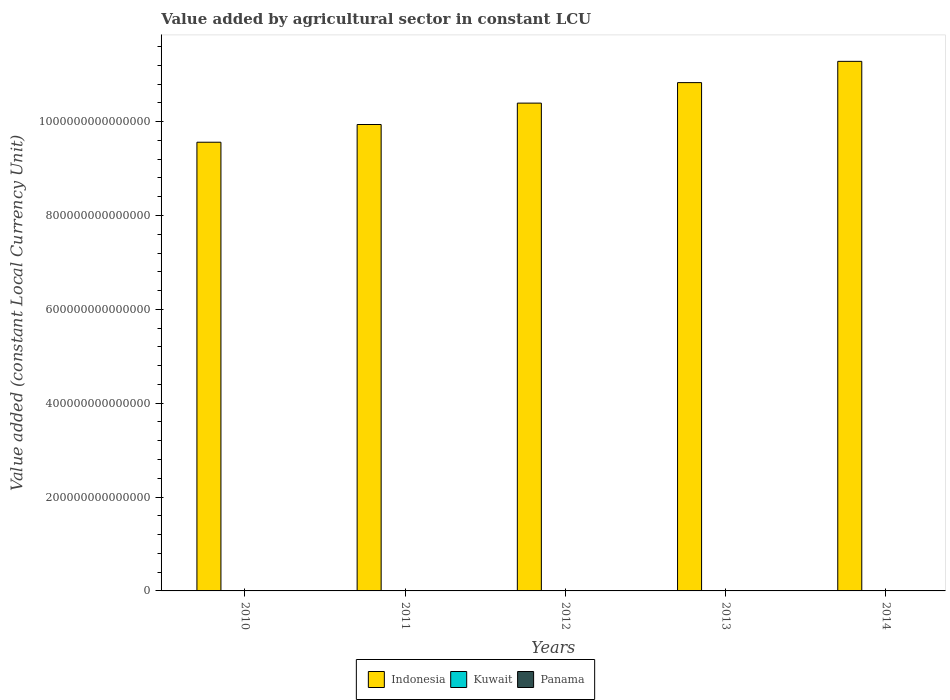Are the number of bars per tick equal to the number of legend labels?
Your answer should be compact. Yes. How many bars are there on the 1st tick from the left?
Keep it short and to the point. 3. What is the label of the 5th group of bars from the left?
Your response must be concise. 2014. What is the value added by agricultural sector in Panama in 2011?
Offer a terse response. 9.27e+08. Across all years, what is the maximum value added by agricultural sector in Kuwait?
Keep it short and to the point. 1.78e+08. Across all years, what is the minimum value added by agricultural sector in Kuwait?
Your response must be concise. 1.49e+08. What is the total value added by agricultural sector in Kuwait in the graph?
Your answer should be very brief. 8.22e+08. What is the difference between the value added by agricultural sector in Panama in 2010 and that in 2013?
Offer a very short reply. -8.93e+07. What is the difference between the value added by agricultural sector in Indonesia in 2010 and the value added by agricultural sector in Panama in 2014?
Offer a very short reply. 9.56e+14. What is the average value added by agricultural sector in Panama per year?
Your answer should be compact. 9.69e+08. In the year 2014, what is the difference between the value added by agricultural sector in Panama and value added by agricultural sector in Indonesia?
Give a very brief answer. -1.13e+15. What is the ratio of the value added by agricultural sector in Panama in 2011 to that in 2012?
Your answer should be compact. 0.96. Is the value added by agricultural sector in Panama in 2013 less than that in 2014?
Your response must be concise. Yes. Is the difference between the value added by agricultural sector in Panama in 2013 and 2014 greater than the difference between the value added by agricultural sector in Indonesia in 2013 and 2014?
Your response must be concise. Yes. What is the difference between the highest and the second highest value added by agricultural sector in Kuwait?
Offer a terse response. 1.22e+07. What is the difference between the highest and the lowest value added by agricultural sector in Panama?
Keep it short and to the point. 1.15e+08. In how many years, is the value added by agricultural sector in Kuwait greater than the average value added by agricultural sector in Kuwait taken over all years?
Provide a succinct answer. 3. What does the 2nd bar from the left in 2012 represents?
Offer a terse response. Kuwait. What does the 3rd bar from the right in 2011 represents?
Provide a short and direct response. Indonesia. Is it the case that in every year, the sum of the value added by agricultural sector in Panama and value added by agricultural sector in Kuwait is greater than the value added by agricultural sector in Indonesia?
Offer a very short reply. No. Are all the bars in the graph horizontal?
Make the answer very short. No. How many years are there in the graph?
Provide a short and direct response. 5. What is the difference between two consecutive major ticks on the Y-axis?
Make the answer very short. 2.00e+14. Are the values on the major ticks of Y-axis written in scientific E-notation?
Ensure brevity in your answer.  No. Does the graph contain grids?
Your response must be concise. No. Where does the legend appear in the graph?
Provide a short and direct response. Bottom center. What is the title of the graph?
Make the answer very short. Value added by agricultural sector in constant LCU. What is the label or title of the Y-axis?
Provide a succinct answer. Value added (constant Local Currency Unit). What is the Value added (constant Local Currency Unit) of Indonesia in 2010?
Your response must be concise. 9.56e+14. What is the Value added (constant Local Currency Unit) in Kuwait in 2010?
Your response must be concise. 1.49e+08. What is the Value added (constant Local Currency Unit) in Panama in 2010?
Offer a terse response. 9.15e+08. What is the Value added (constant Local Currency Unit) of Indonesia in 2011?
Offer a terse response. 9.94e+14. What is the Value added (constant Local Currency Unit) of Kuwait in 2011?
Offer a very short reply. 1.66e+08. What is the Value added (constant Local Currency Unit) in Panama in 2011?
Keep it short and to the point. 9.27e+08. What is the Value added (constant Local Currency Unit) of Indonesia in 2012?
Ensure brevity in your answer.  1.04e+15. What is the Value added (constant Local Currency Unit) in Kuwait in 2012?
Provide a succinct answer. 1.64e+08. What is the Value added (constant Local Currency Unit) of Panama in 2012?
Offer a terse response. 9.70e+08. What is the Value added (constant Local Currency Unit) of Indonesia in 2013?
Provide a succinct answer. 1.08e+15. What is the Value added (constant Local Currency Unit) of Kuwait in 2013?
Ensure brevity in your answer.  1.65e+08. What is the Value added (constant Local Currency Unit) in Panama in 2013?
Provide a succinct answer. 1.00e+09. What is the Value added (constant Local Currency Unit) of Indonesia in 2014?
Ensure brevity in your answer.  1.13e+15. What is the Value added (constant Local Currency Unit) in Kuwait in 2014?
Give a very brief answer. 1.78e+08. What is the Value added (constant Local Currency Unit) in Panama in 2014?
Provide a succinct answer. 1.03e+09. Across all years, what is the maximum Value added (constant Local Currency Unit) of Indonesia?
Offer a very short reply. 1.13e+15. Across all years, what is the maximum Value added (constant Local Currency Unit) of Kuwait?
Provide a succinct answer. 1.78e+08. Across all years, what is the maximum Value added (constant Local Currency Unit) of Panama?
Your answer should be compact. 1.03e+09. Across all years, what is the minimum Value added (constant Local Currency Unit) in Indonesia?
Offer a very short reply. 9.56e+14. Across all years, what is the minimum Value added (constant Local Currency Unit) in Kuwait?
Your response must be concise. 1.49e+08. Across all years, what is the minimum Value added (constant Local Currency Unit) in Panama?
Provide a succinct answer. 9.15e+08. What is the total Value added (constant Local Currency Unit) in Indonesia in the graph?
Offer a very short reply. 5.20e+15. What is the total Value added (constant Local Currency Unit) in Kuwait in the graph?
Your answer should be very brief. 8.22e+08. What is the total Value added (constant Local Currency Unit) of Panama in the graph?
Offer a terse response. 4.85e+09. What is the difference between the Value added (constant Local Currency Unit) in Indonesia in 2010 and that in 2011?
Ensure brevity in your answer.  -3.77e+13. What is the difference between the Value added (constant Local Currency Unit) of Kuwait in 2010 and that in 2011?
Your answer should be very brief. -1.64e+07. What is the difference between the Value added (constant Local Currency Unit) in Panama in 2010 and that in 2011?
Provide a short and direct response. -1.18e+07. What is the difference between the Value added (constant Local Currency Unit) of Indonesia in 2010 and that in 2012?
Your response must be concise. -8.33e+13. What is the difference between the Value added (constant Local Currency Unit) in Kuwait in 2010 and that in 2012?
Ensure brevity in your answer.  -1.43e+07. What is the difference between the Value added (constant Local Currency Unit) in Panama in 2010 and that in 2012?
Your response must be concise. -5.51e+07. What is the difference between the Value added (constant Local Currency Unit) in Indonesia in 2010 and that in 2013?
Provide a short and direct response. -1.27e+14. What is the difference between the Value added (constant Local Currency Unit) of Kuwait in 2010 and that in 2013?
Ensure brevity in your answer.  -1.56e+07. What is the difference between the Value added (constant Local Currency Unit) of Panama in 2010 and that in 2013?
Make the answer very short. -8.93e+07. What is the difference between the Value added (constant Local Currency Unit) of Indonesia in 2010 and that in 2014?
Your answer should be very brief. -1.72e+14. What is the difference between the Value added (constant Local Currency Unit) in Kuwait in 2010 and that in 2014?
Offer a very short reply. -2.86e+07. What is the difference between the Value added (constant Local Currency Unit) of Panama in 2010 and that in 2014?
Provide a succinct answer. -1.15e+08. What is the difference between the Value added (constant Local Currency Unit) of Indonesia in 2011 and that in 2012?
Provide a short and direct response. -4.56e+13. What is the difference between the Value added (constant Local Currency Unit) of Kuwait in 2011 and that in 2012?
Your answer should be very brief. 2.10e+06. What is the difference between the Value added (constant Local Currency Unit) of Panama in 2011 and that in 2012?
Keep it short and to the point. -4.33e+07. What is the difference between the Value added (constant Local Currency Unit) in Indonesia in 2011 and that in 2013?
Provide a succinct answer. -8.93e+13. What is the difference between the Value added (constant Local Currency Unit) of Kuwait in 2011 and that in 2013?
Ensure brevity in your answer.  8.00e+05. What is the difference between the Value added (constant Local Currency Unit) of Panama in 2011 and that in 2013?
Provide a short and direct response. -7.75e+07. What is the difference between the Value added (constant Local Currency Unit) of Indonesia in 2011 and that in 2014?
Offer a terse response. -1.35e+14. What is the difference between the Value added (constant Local Currency Unit) in Kuwait in 2011 and that in 2014?
Offer a terse response. -1.22e+07. What is the difference between the Value added (constant Local Currency Unit) of Panama in 2011 and that in 2014?
Provide a short and direct response. -1.03e+08. What is the difference between the Value added (constant Local Currency Unit) of Indonesia in 2012 and that in 2013?
Your answer should be compact. -4.37e+13. What is the difference between the Value added (constant Local Currency Unit) in Kuwait in 2012 and that in 2013?
Offer a very short reply. -1.30e+06. What is the difference between the Value added (constant Local Currency Unit) of Panama in 2012 and that in 2013?
Keep it short and to the point. -3.42e+07. What is the difference between the Value added (constant Local Currency Unit) in Indonesia in 2012 and that in 2014?
Provide a succinct answer. -8.90e+13. What is the difference between the Value added (constant Local Currency Unit) of Kuwait in 2012 and that in 2014?
Provide a short and direct response. -1.43e+07. What is the difference between the Value added (constant Local Currency Unit) of Panama in 2012 and that in 2014?
Provide a short and direct response. -6.01e+07. What is the difference between the Value added (constant Local Currency Unit) of Indonesia in 2013 and that in 2014?
Ensure brevity in your answer.  -4.53e+13. What is the difference between the Value added (constant Local Currency Unit) of Kuwait in 2013 and that in 2014?
Offer a very short reply. -1.30e+07. What is the difference between the Value added (constant Local Currency Unit) of Panama in 2013 and that in 2014?
Offer a terse response. -2.59e+07. What is the difference between the Value added (constant Local Currency Unit) of Indonesia in 2010 and the Value added (constant Local Currency Unit) of Kuwait in 2011?
Your answer should be very brief. 9.56e+14. What is the difference between the Value added (constant Local Currency Unit) in Indonesia in 2010 and the Value added (constant Local Currency Unit) in Panama in 2011?
Your answer should be very brief. 9.56e+14. What is the difference between the Value added (constant Local Currency Unit) in Kuwait in 2010 and the Value added (constant Local Currency Unit) in Panama in 2011?
Your answer should be very brief. -7.78e+08. What is the difference between the Value added (constant Local Currency Unit) of Indonesia in 2010 and the Value added (constant Local Currency Unit) of Kuwait in 2012?
Offer a terse response. 9.56e+14. What is the difference between the Value added (constant Local Currency Unit) in Indonesia in 2010 and the Value added (constant Local Currency Unit) in Panama in 2012?
Your answer should be compact. 9.56e+14. What is the difference between the Value added (constant Local Currency Unit) of Kuwait in 2010 and the Value added (constant Local Currency Unit) of Panama in 2012?
Your answer should be very brief. -8.21e+08. What is the difference between the Value added (constant Local Currency Unit) of Indonesia in 2010 and the Value added (constant Local Currency Unit) of Kuwait in 2013?
Give a very brief answer. 9.56e+14. What is the difference between the Value added (constant Local Currency Unit) in Indonesia in 2010 and the Value added (constant Local Currency Unit) in Panama in 2013?
Your answer should be very brief. 9.56e+14. What is the difference between the Value added (constant Local Currency Unit) of Kuwait in 2010 and the Value added (constant Local Currency Unit) of Panama in 2013?
Offer a terse response. -8.55e+08. What is the difference between the Value added (constant Local Currency Unit) of Indonesia in 2010 and the Value added (constant Local Currency Unit) of Kuwait in 2014?
Make the answer very short. 9.56e+14. What is the difference between the Value added (constant Local Currency Unit) in Indonesia in 2010 and the Value added (constant Local Currency Unit) in Panama in 2014?
Give a very brief answer. 9.56e+14. What is the difference between the Value added (constant Local Currency Unit) in Kuwait in 2010 and the Value added (constant Local Currency Unit) in Panama in 2014?
Offer a terse response. -8.81e+08. What is the difference between the Value added (constant Local Currency Unit) of Indonesia in 2011 and the Value added (constant Local Currency Unit) of Kuwait in 2012?
Provide a succinct answer. 9.94e+14. What is the difference between the Value added (constant Local Currency Unit) in Indonesia in 2011 and the Value added (constant Local Currency Unit) in Panama in 2012?
Give a very brief answer. 9.94e+14. What is the difference between the Value added (constant Local Currency Unit) of Kuwait in 2011 and the Value added (constant Local Currency Unit) of Panama in 2012?
Your answer should be very brief. -8.04e+08. What is the difference between the Value added (constant Local Currency Unit) in Indonesia in 2011 and the Value added (constant Local Currency Unit) in Kuwait in 2013?
Ensure brevity in your answer.  9.94e+14. What is the difference between the Value added (constant Local Currency Unit) in Indonesia in 2011 and the Value added (constant Local Currency Unit) in Panama in 2013?
Ensure brevity in your answer.  9.94e+14. What is the difference between the Value added (constant Local Currency Unit) of Kuwait in 2011 and the Value added (constant Local Currency Unit) of Panama in 2013?
Give a very brief answer. -8.39e+08. What is the difference between the Value added (constant Local Currency Unit) in Indonesia in 2011 and the Value added (constant Local Currency Unit) in Kuwait in 2014?
Your answer should be very brief. 9.94e+14. What is the difference between the Value added (constant Local Currency Unit) in Indonesia in 2011 and the Value added (constant Local Currency Unit) in Panama in 2014?
Keep it short and to the point. 9.94e+14. What is the difference between the Value added (constant Local Currency Unit) of Kuwait in 2011 and the Value added (constant Local Currency Unit) of Panama in 2014?
Your response must be concise. -8.64e+08. What is the difference between the Value added (constant Local Currency Unit) in Indonesia in 2012 and the Value added (constant Local Currency Unit) in Kuwait in 2013?
Offer a terse response. 1.04e+15. What is the difference between the Value added (constant Local Currency Unit) in Indonesia in 2012 and the Value added (constant Local Currency Unit) in Panama in 2013?
Make the answer very short. 1.04e+15. What is the difference between the Value added (constant Local Currency Unit) of Kuwait in 2012 and the Value added (constant Local Currency Unit) of Panama in 2013?
Your response must be concise. -8.41e+08. What is the difference between the Value added (constant Local Currency Unit) in Indonesia in 2012 and the Value added (constant Local Currency Unit) in Kuwait in 2014?
Your response must be concise. 1.04e+15. What is the difference between the Value added (constant Local Currency Unit) in Indonesia in 2012 and the Value added (constant Local Currency Unit) in Panama in 2014?
Provide a succinct answer. 1.04e+15. What is the difference between the Value added (constant Local Currency Unit) in Kuwait in 2012 and the Value added (constant Local Currency Unit) in Panama in 2014?
Make the answer very short. -8.67e+08. What is the difference between the Value added (constant Local Currency Unit) in Indonesia in 2013 and the Value added (constant Local Currency Unit) in Kuwait in 2014?
Provide a succinct answer. 1.08e+15. What is the difference between the Value added (constant Local Currency Unit) in Indonesia in 2013 and the Value added (constant Local Currency Unit) in Panama in 2014?
Your answer should be compact. 1.08e+15. What is the difference between the Value added (constant Local Currency Unit) in Kuwait in 2013 and the Value added (constant Local Currency Unit) in Panama in 2014?
Your answer should be compact. -8.65e+08. What is the average Value added (constant Local Currency Unit) in Indonesia per year?
Ensure brevity in your answer.  1.04e+15. What is the average Value added (constant Local Currency Unit) of Kuwait per year?
Your answer should be compact. 1.64e+08. What is the average Value added (constant Local Currency Unit) of Panama per year?
Ensure brevity in your answer.  9.69e+08. In the year 2010, what is the difference between the Value added (constant Local Currency Unit) of Indonesia and Value added (constant Local Currency Unit) of Kuwait?
Provide a short and direct response. 9.56e+14. In the year 2010, what is the difference between the Value added (constant Local Currency Unit) in Indonesia and Value added (constant Local Currency Unit) in Panama?
Offer a terse response. 9.56e+14. In the year 2010, what is the difference between the Value added (constant Local Currency Unit) of Kuwait and Value added (constant Local Currency Unit) of Panama?
Ensure brevity in your answer.  -7.66e+08. In the year 2011, what is the difference between the Value added (constant Local Currency Unit) in Indonesia and Value added (constant Local Currency Unit) in Kuwait?
Your answer should be compact. 9.94e+14. In the year 2011, what is the difference between the Value added (constant Local Currency Unit) of Indonesia and Value added (constant Local Currency Unit) of Panama?
Give a very brief answer. 9.94e+14. In the year 2011, what is the difference between the Value added (constant Local Currency Unit) in Kuwait and Value added (constant Local Currency Unit) in Panama?
Give a very brief answer. -7.61e+08. In the year 2012, what is the difference between the Value added (constant Local Currency Unit) in Indonesia and Value added (constant Local Currency Unit) in Kuwait?
Your response must be concise. 1.04e+15. In the year 2012, what is the difference between the Value added (constant Local Currency Unit) in Indonesia and Value added (constant Local Currency Unit) in Panama?
Ensure brevity in your answer.  1.04e+15. In the year 2012, what is the difference between the Value added (constant Local Currency Unit) in Kuwait and Value added (constant Local Currency Unit) in Panama?
Your answer should be compact. -8.06e+08. In the year 2013, what is the difference between the Value added (constant Local Currency Unit) in Indonesia and Value added (constant Local Currency Unit) in Kuwait?
Your answer should be compact. 1.08e+15. In the year 2013, what is the difference between the Value added (constant Local Currency Unit) of Indonesia and Value added (constant Local Currency Unit) of Panama?
Your answer should be compact. 1.08e+15. In the year 2013, what is the difference between the Value added (constant Local Currency Unit) in Kuwait and Value added (constant Local Currency Unit) in Panama?
Your answer should be compact. -8.39e+08. In the year 2014, what is the difference between the Value added (constant Local Currency Unit) in Indonesia and Value added (constant Local Currency Unit) in Kuwait?
Make the answer very short. 1.13e+15. In the year 2014, what is the difference between the Value added (constant Local Currency Unit) of Indonesia and Value added (constant Local Currency Unit) of Panama?
Make the answer very short. 1.13e+15. In the year 2014, what is the difference between the Value added (constant Local Currency Unit) of Kuwait and Value added (constant Local Currency Unit) of Panama?
Provide a succinct answer. -8.52e+08. What is the ratio of the Value added (constant Local Currency Unit) of Indonesia in 2010 to that in 2011?
Your response must be concise. 0.96. What is the ratio of the Value added (constant Local Currency Unit) in Kuwait in 2010 to that in 2011?
Your answer should be very brief. 0.9. What is the ratio of the Value added (constant Local Currency Unit) of Panama in 2010 to that in 2011?
Provide a short and direct response. 0.99. What is the ratio of the Value added (constant Local Currency Unit) in Indonesia in 2010 to that in 2012?
Provide a short and direct response. 0.92. What is the ratio of the Value added (constant Local Currency Unit) in Kuwait in 2010 to that in 2012?
Ensure brevity in your answer.  0.91. What is the ratio of the Value added (constant Local Currency Unit) of Panama in 2010 to that in 2012?
Your answer should be compact. 0.94. What is the ratio of the Value added (constant Local Currency Unit) in Indonesia in 2010 to that in 2013?
Offer a very short reply. 0.88. What is the ratio of the Value added (constant Local Currency Unit) of Kuwait in 2010 to that in 2013?
Your response must be concise. 0.91. What is the ratio of the Value added (constant Local Currency Unit) of Panama in 2010 to that in 2013?
Make the answer very short. 0.91. What is the ratio of the Value added (constant Local Currency Unit) in Indonesia in 2010 to that in 2014?
Your response must be concise. 0.85. What is the ratio of the Value added (constant Local Currency Unit) in Kuwait in 2010 to that in 2014?
Offer a terse response. 0.84. What is the ratio of the Value added (constant Local Currency Unit) in Panama in 2010 to that in 2014?
Your answer should be compact. 0.89. What is the ratio of the Value added (constant Local Currency Unit) in Indonesia in 2011 to that in 2012?
Your answer should be compact. 0.96. What is the ratio of the Value added (constant Local Currency Unit) in Kuwait in 2011 to that in 2012?
Give a very brief answer. 1.01. What is the ratio of the Value added (constant Local Currency Unit) of Panama in 2011 to that in 2012?
Ensure brevity in your answer.  0.96. What is the ratio of the Value added (constant Local Currency Unit) in Indonesia in 2011 to that in 2013?
Offer a very short reply. 0.92. What is the ratio of the Value added (constant Local Currency Unit) in Panama in 2011 to that in 2013?
Your response must be concise. 0.92. What is the ratio of the Value added (constant Local Currency Unit) in Indonesia in 2011 to that in 2014?
Provide a succinct answer. 0.88. What is the ratio of the Value added (constant Local Currency Unit) of Kuwait in 2011 to that in 2014?
Your answer should be compact. 0.93. What is the ratio of the Value added (constant Local Currency Unit) in Panama in 2011 to that in 2014?
Your answer should be compact. 0.9. What is the ratio of the Value added (constant Local Currency Unit) in Indonesia in 2012 to that in 2013?
Provide a short and direct response. 0.96. What is the ratio of the Value added (constant Local Currency Unit) of Kuwait in 2012 to that in 2013?
Give a very brief answer. 0.99. What is the ratio of the Value added (constant Local Currency Unit) in Panama in 2012 to that in 2013?
Your answer should be very brief. 0.97. What is the ratio of the Value added (constant Local Currency Unit) in Indonesia in 2012 to that in 2014?
Your answer should be compact. 0.92. What is the ratio of the Value added (constant Local Currency Unit) in Kuwait in 2012 to that in 2014?
Ensure brevity in your answer.  0.92. What is the ratio of the Value added (constant Local Currency Unit) in Panama in 2012 to that in 2014?
Your response must be concise. 0.94. What is the ratio of the Value added (constant Local Currency Unit) in Indonesia in 2013 to that in 2014?
Your response must be concise. 0.96. What is the ratio of the Value added (constant Local Currency Unit) in Kuwait in 2013 to that in 2014?
Your response must be concise. 0.93. What is the ratio of the Value added (constant Local Currency Unit) in Panama in 2013 to that in 2014?
Provide a short and direct response. 0.97. What is the difference between the highest and the second highest Value added (constant Local Currency Unit) in Indonesia?
Offer a terse response. 4.53e+13. What is the difference between the highest and the second highest Value added (constant Local Currency Unit) in Kuwait?
Your answer should be very brief. 1.22e+07. What is the difference between the highest and the second highest Value added (constant Local Currency Unit) in Panama?
Provide a succinct answer. 2.59e+07. What is the difference between the highest and the lowest Value added (constant Local Currency Unit) in Indonesia?
Make the answer very short. 1.72e+14. What is the difference between the highest and the lowest Value added (constant Local Currency Unit) of Kuwait?
Provide a succinct answer. 2.86e+07. What is the difference between the highest and the lowest Value added (constant Local Currency Unit) of Panama?
Make the answer very short. 1.15e+08. 